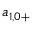Convert formula to latex. <formula><loc_0><loc_0><loc_500><loc_500>a _ { 1 , 0 + }</formula> 